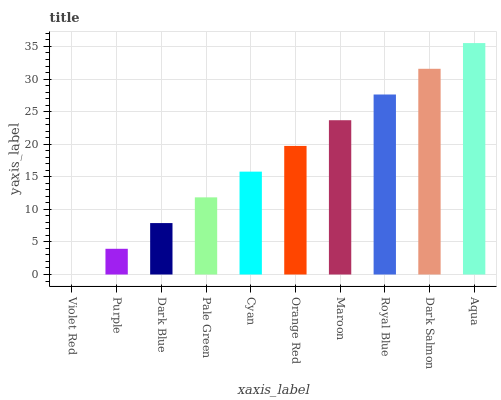Is Violet Red the minimum?
Answer yes or no. Yes. Is Aqua the maximum?
Answer yes or no. Yes. Is Purple the minimum?
Answer yes or no. No. Is Purple the maximum?
Answer yes or no. No. Is Purple greater than Violet Red?
Answer yes or no. Yes. Is Violet Red less than Purple?
Answer yes or no. Yes. Is Violet Red greater than Purple?
Answer yes or no. No. Is Purple less than Violet Red?
Answer yes or no. No. Is Orange Red the high median?
Answer yes or no. Yes. Is Cyan the low median?
Answer yes or no. Yes. Is Aqua the high median?
Answer yes or no. No. Is Maroon the low median?
Answer yes or no. No. 